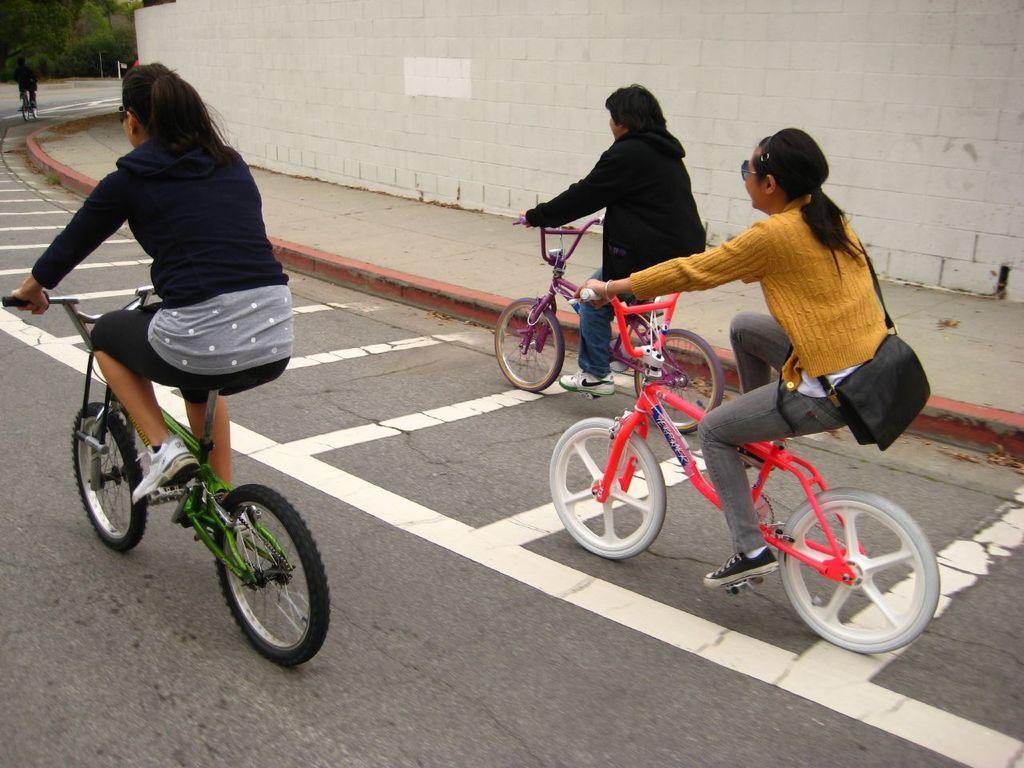In one or two sentences, can you explain what this image depicts? In this picture we can see three persons on the bicycle. She is carrying her bag. This is road and there is a wall. 